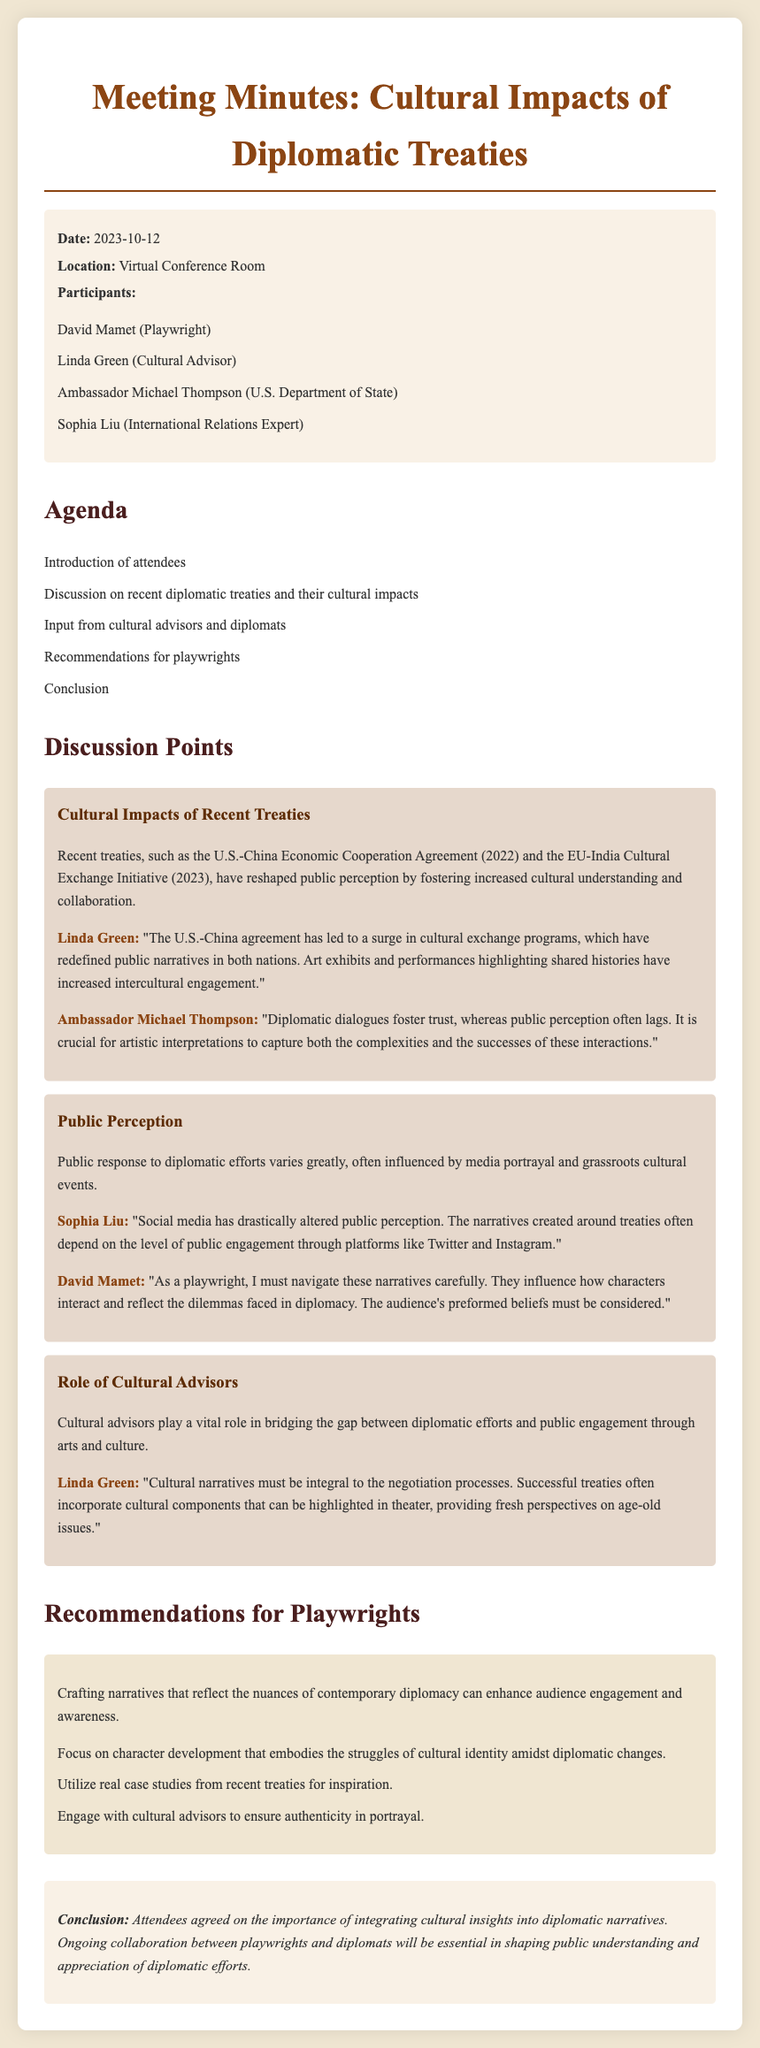What is the date of the meeting? The date of the meeting is mentioned in the document's info section as 2023-10-12.
Answer: 2023-10-12 Who is one of the participants listed in the document? The document lists several participants; one of them is David Mamet.
Answer: David Mamet What initiative was discussed regarding the EU? The document mentions the EU-India Cultural Exchange Initiative from 2023.
Answer: EU-India Cultural Exchange Initiative What does Linda Green emphasize about cultural narratives? Linda Green states that cultural narratives must be integral to the negotiation processes, as highlighted in her speech.
Answer: Integral to the negotiation processes How does Sophia Liu describe the influence of social media? Sophia Liu suggests that social media has drastically altered public perception, as discussed in her comments.
Answer: Drastically altered public perception What is the main conclusion of the meeting? The conclusion emphasizes the importance of integrating cultural insights into diplomatic narratives.
Answer: Integrating cultural insights into diplomatic narratives What should playwrights focus on according to the recommendations? Playwrights should focus on character development that embodies the struggles of cultural identity amidst diplomatic changes.
Answer: Character development Who provided input on the public perception of diplomatic efforts? Sophia Liu provided input on the public perception influenced by media portrayal and grassroots events.
Answer: Sophia Liu What type of advisor's role is highlighted in the discussion? The role of cultural advisors is highlighted in the document as vital for bridging the gap between diplomacy and public engagement.
Answer: Cultural advisors 